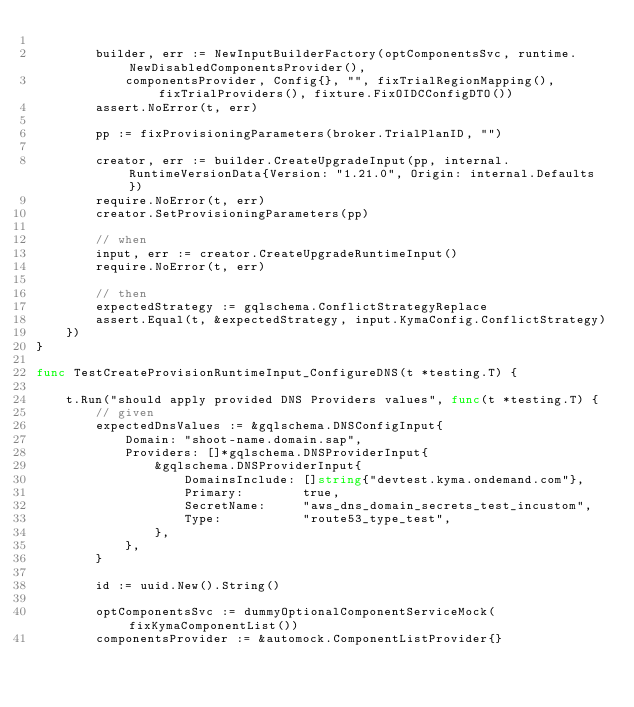<code> <loc_0><loc_0><loc_500><loc_500><_Go_>
		builder, err := NewInputBuilderFactory(optComponentsSvc, runtime.NewDisabledComponentsProvider(),
			componentsProvider, Config{}, "", fixTrialRegionMapping(), fixTrialProviders(), fixture.FixOIDCConfigDTO())
		assert.NoError(t, err)

		pp := fixProvisioningParameters(broker.TrialPlanID, "")

		creator, err := builder.CreateUpgradeInput(pp, internal.RuntimeVersionData{Version: "1.21.0", Origin: internal.Defaults})
		require.NoError(t, err)
		creator.SetProvisioningParameters(pp)

		// when
		input, err := creator.CreateUpgradeRuntimeInput()
		require.NoError(t, err)

		// then
		expectedStrategy := gqlschema.ConflictStrategyReplace
		assert.Equal(t, &expectedStrategy, input.KymaConfig.ConflictStrategy)
	})
}

func TestCreateProvisionRuntimeInput_ConfigureDNS(t *testing.T) {

	t.Run("should apply provided DNS Providers values", func(t *testing.T) {
		// given
		expectedDnsValues := &gqlschema.DNSConfigInput{
			Domain: "shoot-name.domain.sap",
			Providers: []*gqlschema.DNSProviderInput{
				&gqlschema.DNSProviderInput{
					DomainsInclude: []string{"devtest.kyma.ondemand.com"},
					Primary:        true,
					SecretName:     "aws_dns_domain_secrets_test_incustom",
					Type:           "route53_type_test",
				},
			},
		}

		id := uuid.New().String()

		optComponentsSvc := dummyOptionalComponentServiceMock(fixKymaComponentList())
		componentsProvider := &automock.ComponentListProvider{}</code> 